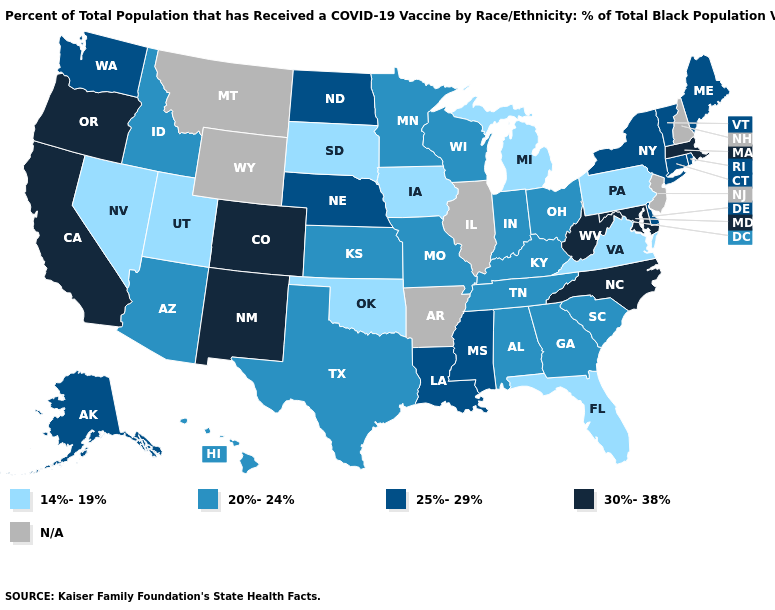Name the states that have a value in the range 14%-19%?
Keep it brief. Florida, Iowa, Michigan, Nevada, Oklahoma, Pennsylvania, South Dakota, Utah, Virginia. Does Massachusetts have the highest value in the Northeast?
Short answer required. Yes. Does the map have missing data?
Be succinct. Yes. What is the value of Minnesota?
Be succinct. 20%-24%. What is the highest value in the South ?
Write a very short answer. 30%-38%. Name the states that have a value in the range N/A?
Quick response, please. Arkansas, Illinois, Montana, New Hampshire, New Jersey, Wyoming. Name the states that have a value in the range 14%-19%?
Concise answer only. Florida, Iowa, Michigan, Nevada, Oklahoma, Pennsylvania, South Dakota, Utah, Virginia. Among the states that border Utah , which have the lowest value?
Be succinct. Nevada. What is the lowest value in the MidWest?
Quick response, please. 14%-19%. What is the value of Wyoming?
Be succinct. N/A. What is the value of Nebraska?
Be succinct. 25%-29%. What is the value of Illinois?
Concise answer only. N/A. Name the states that have a value in the range N/A?
Answer briefly. Arkansas, Illinois, Montana, New Hampshire, New Jersey, Wyoming. What is the value of Nevada?
Give a very brief answer. 14%-19%. Is the legend a continuous bar?
Be succinct. No. 